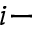Convert formula to latex. <formula><loc_0><loc_0><loc_500><loc_500>i -</formula> 